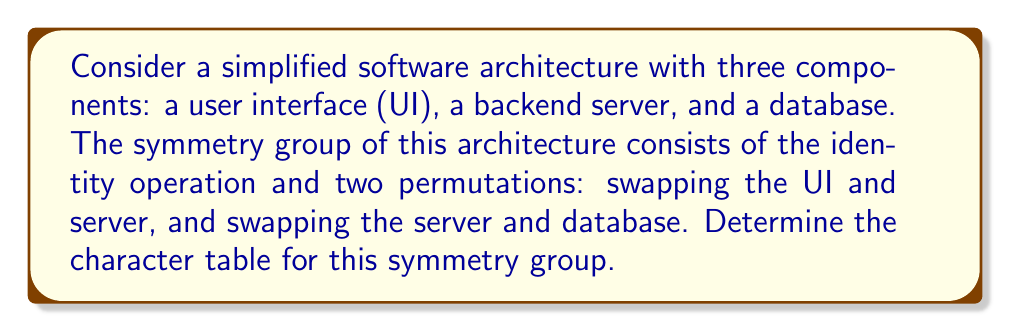Teach me how to tackle this problem. Let's approach this step-by-step:

1) First, we need to identify the group elements:
   e: identity
   a: swap UI and server
   b: swap server and database

2) This group is isomorphic to the cyclic group $C_3$, as $a^2 = b$, $b^2 = a$, and $ab = ba = e$.

3) For a group of order 3, we know there will be 3 irreducible representations, corresponding to the 3 conjugacy classes: {e}, {a}, and {b}.

4) The character table will be a 3x3 matrix. Let's call the irreducible representations $\chi_1$, $\chi_2$, and $\chi_3$.

5) $\chi_1$ is always the trivial representation, giving 1 for all elements:
   $\chi_1: 1, 1, 1$

6) For $\chi_2$ and $\chi_3$, we can use the complex cube roots of unity:
   $\omega = e^{2\pi i/3} = -\frac{1}{2} + i\frac{\sqrt{3}}{2}$
   $\omega^2 = e^{4\pi i/3} = -\frac{1}{2} - i\frac{\sqrt{3}}{2}$

7) $\chi_2$ will be:
   $\chi_2: 1, \omega, \omega^2$

8) $\chi_3$ will be the complex conjugate of $\chi_2$:
   $\chi_3: 1, \omega^2, \omega$

9) Therefore, the character table is:

   $$
   \begin{array}{c|ccc}
    & e & a & b \\
   \hline
   \chi_1 & 1 & 1 & 1 \\
   \chi_2 & 1 & \omega & \omega^2 \\
   \chi_3 & 1 & \omega^2 & \omega
   \end{array}
   $$

   where $\omega = e^{2\pi i/3} = -\frac{1}{2} + i\frac{\sqrt{3}}{2}$
Answer: $$
\begin{array}{c|ccc}
 & e & a & b \\
\hline
\chi_1 & 1 & 1 & 1 \\
\chi_2 & 1 & \omega & \omega^2 \\
\chi_3 & 1 & \omega^2 & \omega
\end{array}
$$
where $\omega = e^{2\pi i/3}$ 